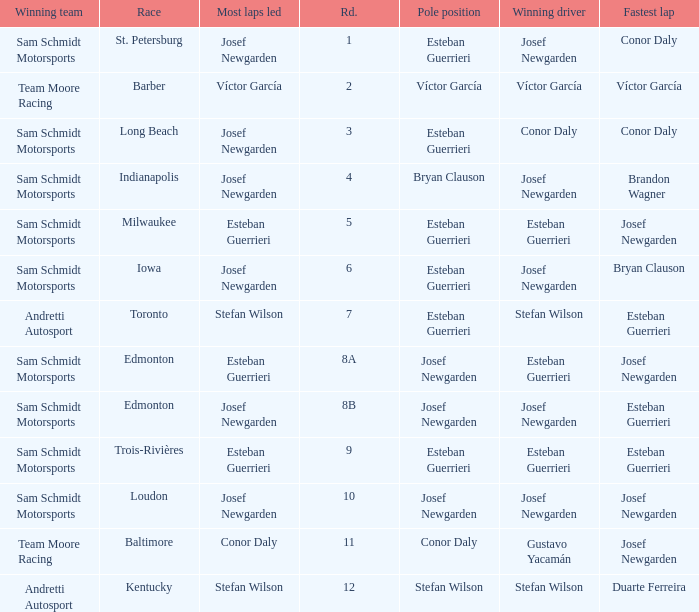Who had the fastest lap(s) when josef newgarden led the most laps at edmonton? Esteban Guerrieri. 